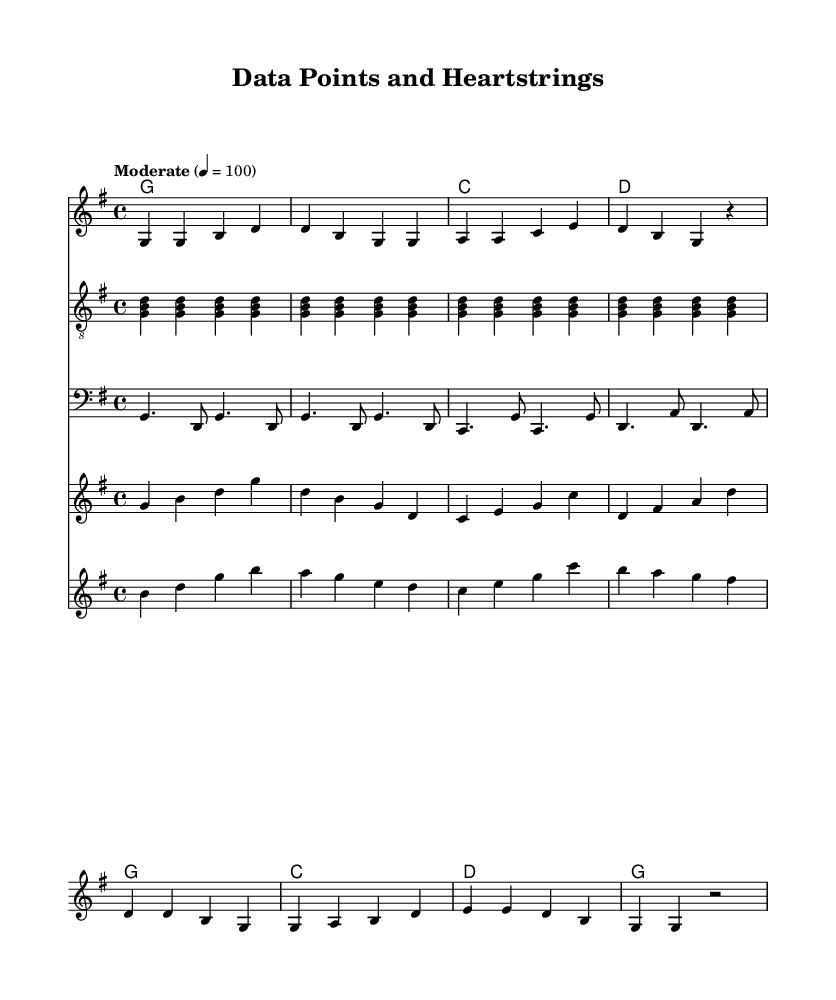What is the key signature of this music? The key signature is indicated at the beginning of the sheet music and shows one sharp, which corresponds to G major (or E minor).
Answer: G major What is the time signature of this music? The time signature is located at the beginning of the sheet music in the bottom left corner, showing 4 beats per measure, which is commonly represented as 4/4.
Answer: 4/4 What is the tempo marking for this piece? The tempo marking is found at the beginning, indicating "Moderate" with a metronome marking of 100 beats per minute, helping to set the speed of the music.
Answer: Moderate How many verses are presented in the song? The song structure shows one verse followed by a chorus, with no indication of additional verses in the provided music, thus indicating one verse.
Answer: One What are the two main sections of this song called? The two main sections are labeled clearly in the music, with one part referred to as the verse and the other as the chorus, which are typical of song structure.
Answer: Verse and Chorus What is the primary theme of the lyrics? The lyrics discuss themes of data analysis and problem-solving, relating both to analytical work and emotional expressions typical of country songs, combining these areas.
Answer: Data analysis and problem-solving 